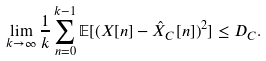Convert formula to latex. <formula><loc_0><loc_0><loc_500><loc_500>\lim _ { k \to \infty } \frac { 1 } { k } \sum _ { n = 0 } ^ { k - 1 } \mathbb { E } [ ( X [ n ] - \hat { X } _ { C } [ n ] ) ^ { 2 } ] \leq D _ { C } .</formula> 